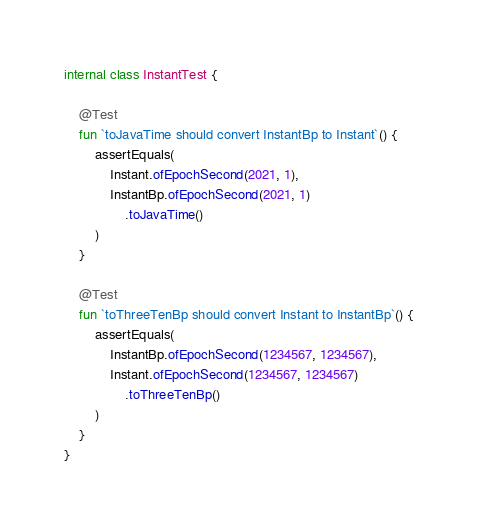<code> <loc_0><loc_0><loc_500><loc_500><_Kotlin_>
internal class InstantTest {

    @Test
    fun `toJavaTime should convert InstantBp to Instant`() {
        assertEquals(
            Instant.ofEpochSecond(2021, 1),
            InstantBp.ofEpochSecond(2021, 1)
                .toJavaTime()
        )
    }

    @Test
    fun `toThreeTenBp should convert Instant to InstantBp`() {
        assertEquals(
            InstantBp.ofEpochSecond(1234567, 1234567),
            Instant.ofEpochSecond(1234567, 1234567)
                .toThreeTenBp()
        )
    }
}
</code> 